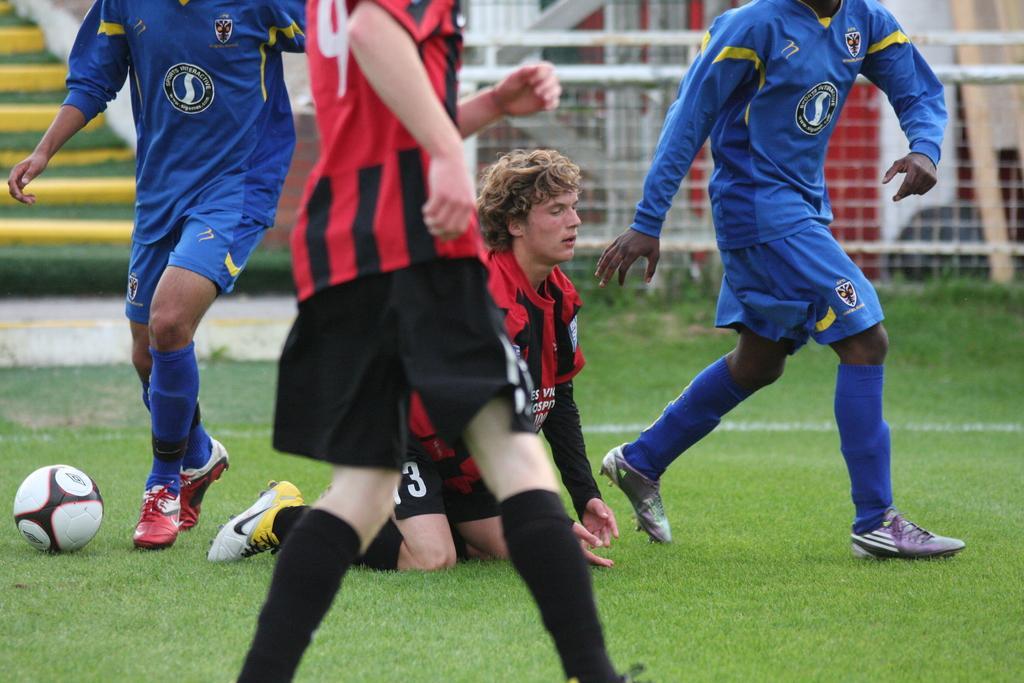Describe this image in one or two sentences. In this image we can see players and ball on the grass. In the background we can see fencing and stairs. 